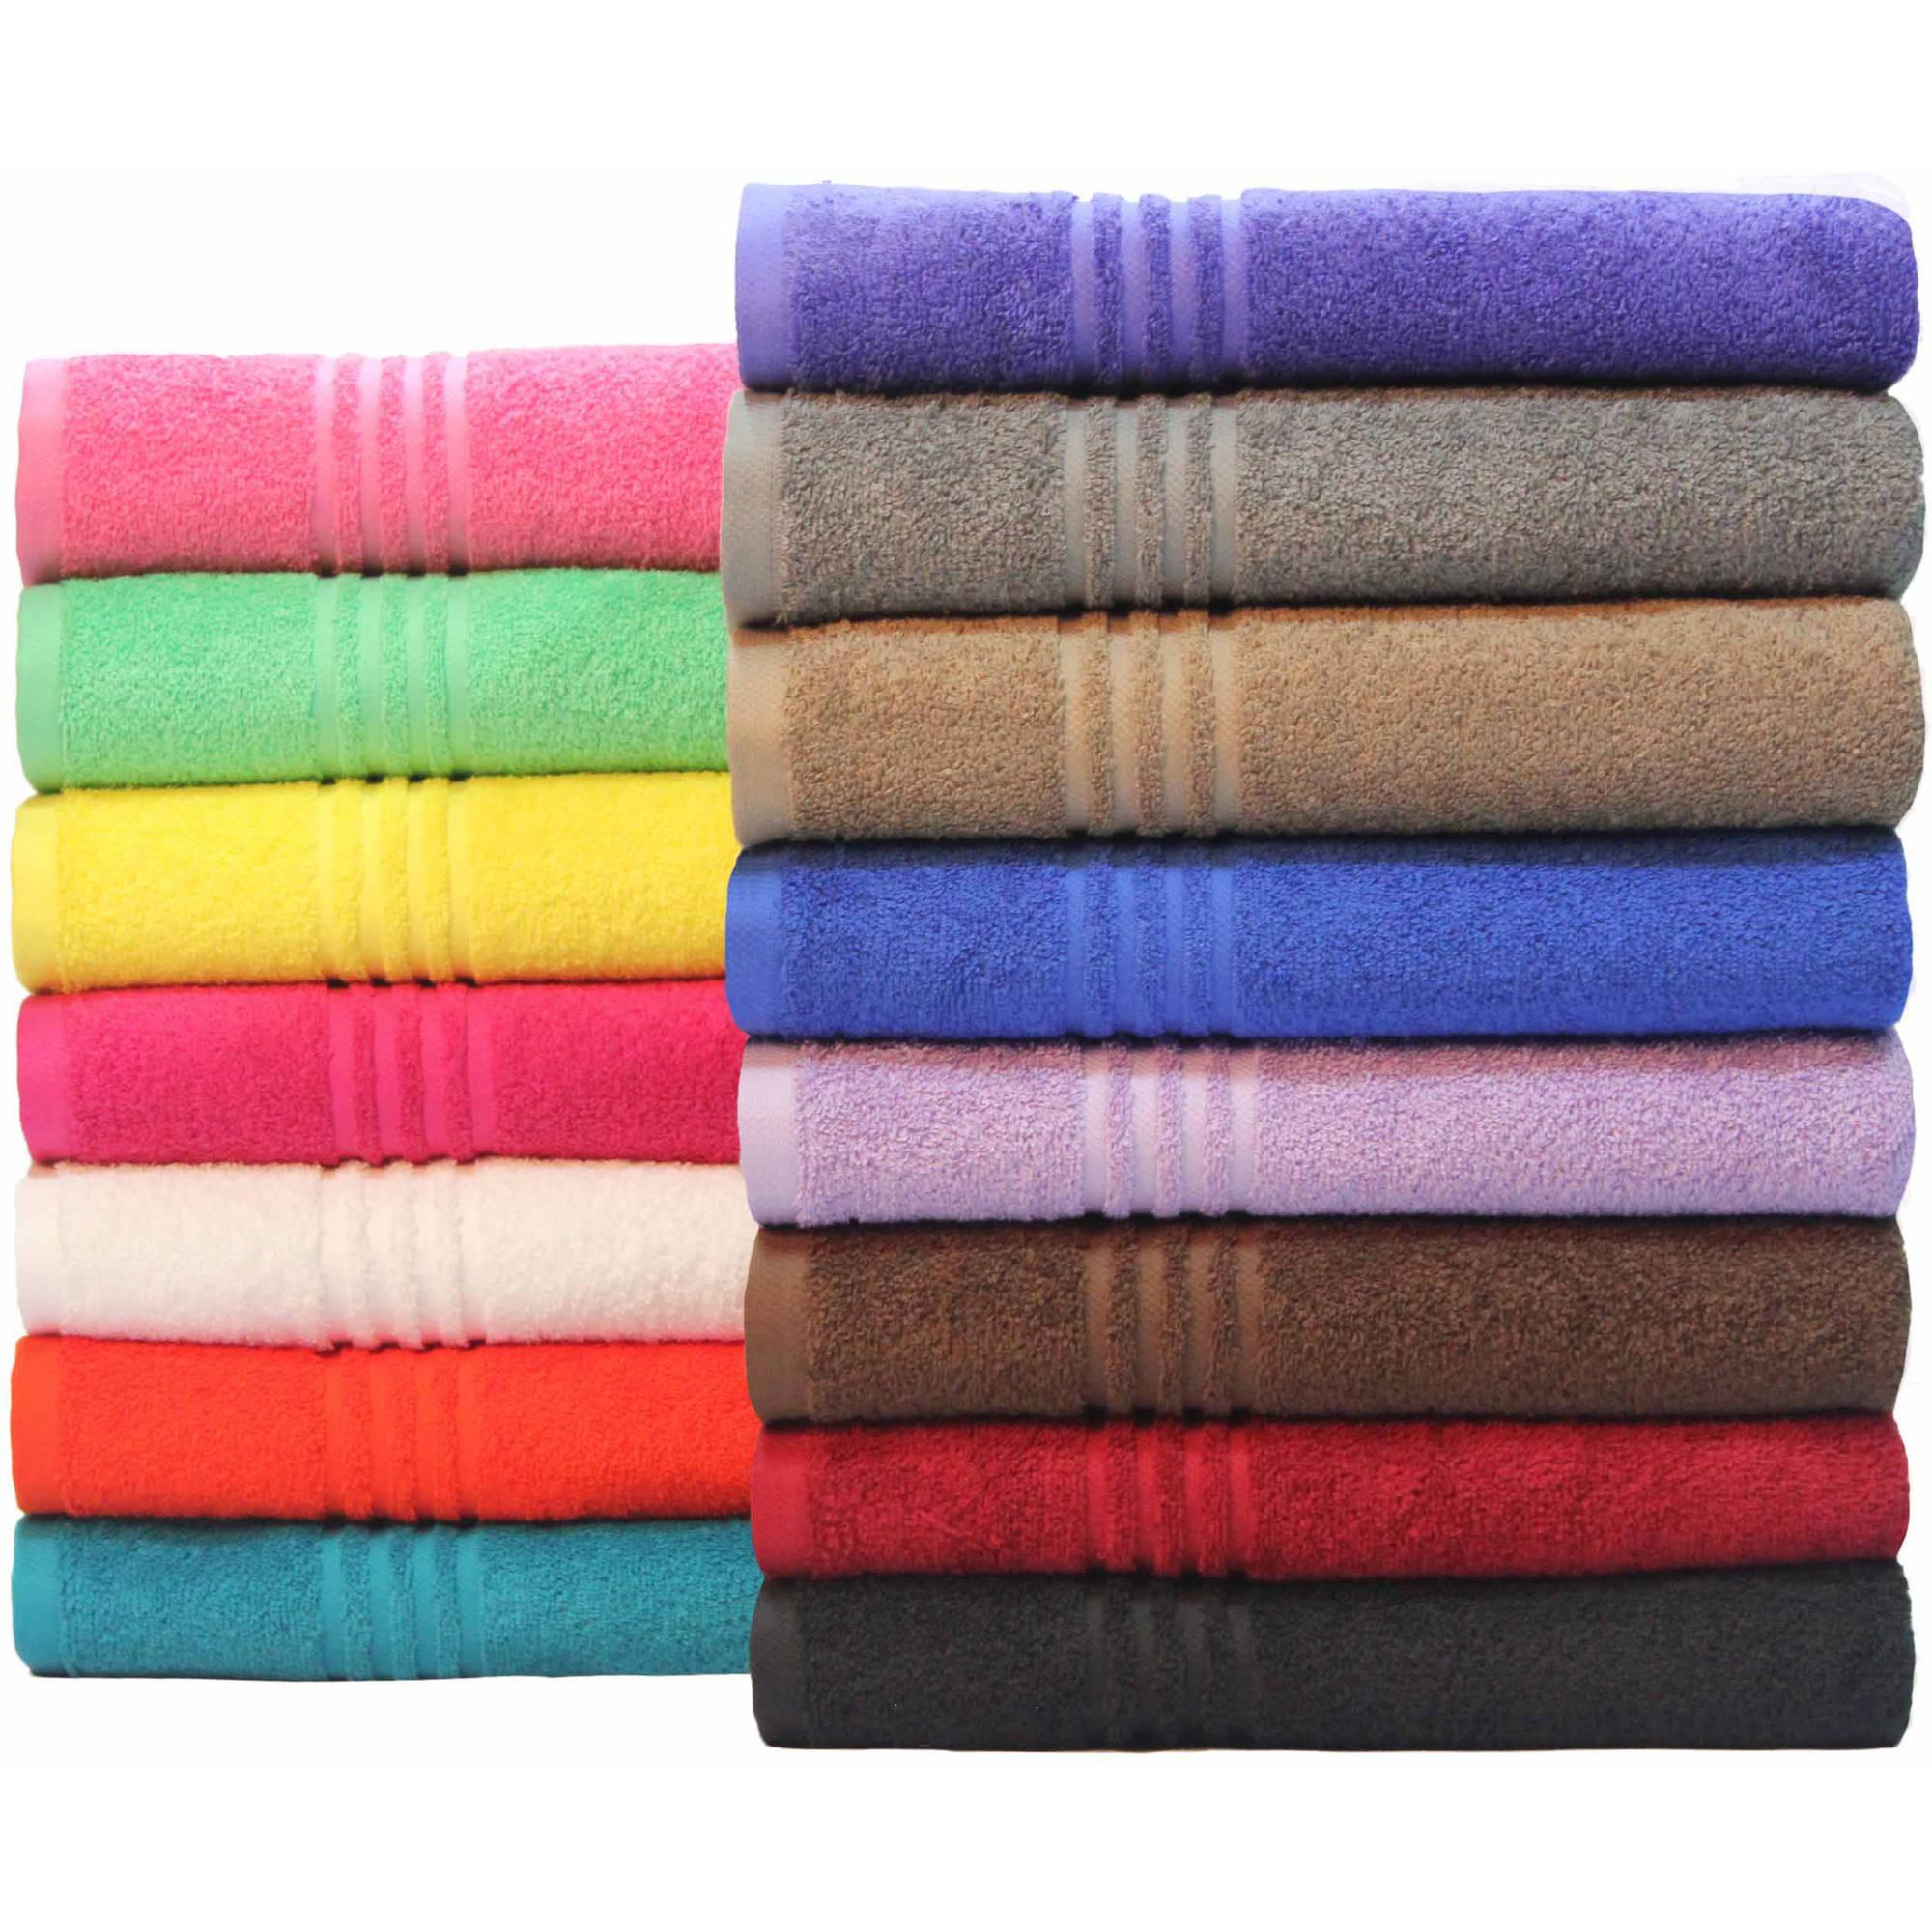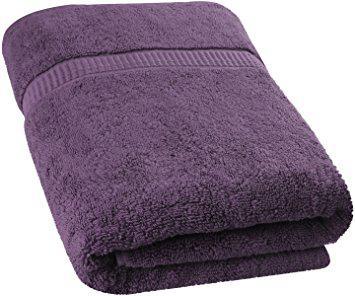The first image is the image on the left, the second image is the image on the right. Examine the images to the left and right. Is the description "Three white towels are stacked on each other in the image on the left." accurate? Answer yes or no. No. The first image is the image on the left, the second image is the image on the right. For the images shown, is this caption "One image features a stack of exactly three solid white folded towels." true? Answer yes or no. No. 